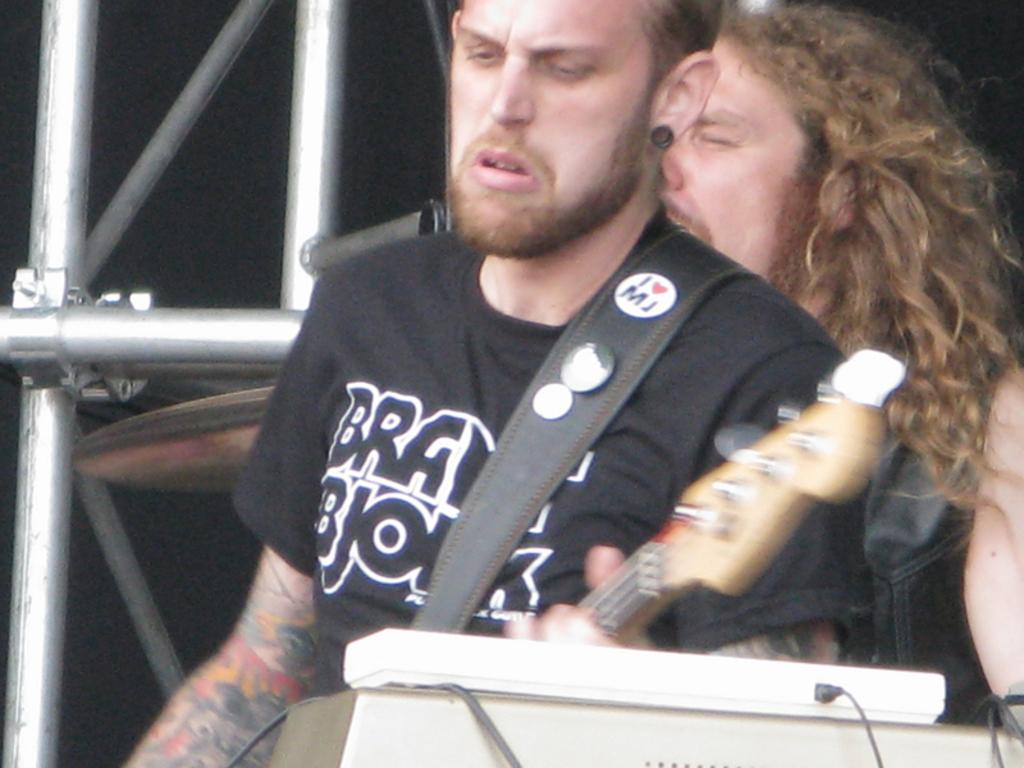How many people are in the image? There are two people in the image. What are the people doing in the image? The people are standing in front of a microphone and playing a guitar. What can be seen near the people in the image? There are poles near the people. What type of glove is the person wearing while playing the guitar in the image? There is no glove visible on the person playing the guitar in the image. What is the opinion of the person on the left about the song they are playing? The image does not provide any information about the person's opinion on the song they are playing. 